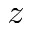<formula> <loc_0><loc_0><loc_500><loc_500>z</formula> 